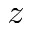<formula> <loc_0><loc_0><loc_500><loc_500>z</formula> 